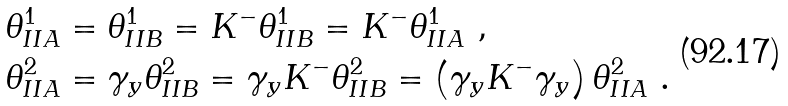<formula> <loc_0><loc_0><loc_500><loc_500>\theta _ { I I A } ^ { 1 } & = \theta _ { I I B } ^ { 1 } = K ^ { - } \theta _ { I I B } ^ { 1 } = K ^ { - } \theta _ { I I A } ^ { 1 } \ , \\ \theta _ { I I A } ^ { 2 } & = \gamma _ { y } \theta _ { I I B } ^ { 2 } = \gamma _ { y } K ^ { - } \theta _ { I I B } ^ { 2 } = \left ( \gamma _ { y } K ^ { - } \gamma _ { y } \right ) \theta _ { I I A } ^ { 2 } \ .</formula> 